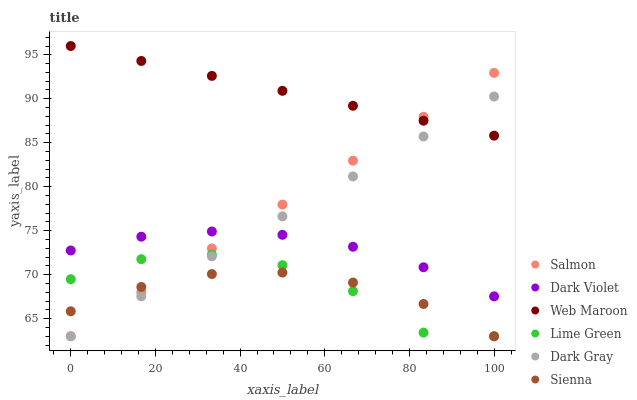Does Sienna have the minimum area under the curve?
Answer yes or no. Yes. Does Web Maroon have the maximum area under the curve?
Answer yes or no. Yes. Does Salmon have the minimum area under the curve?
Answer yes or no. No. Does Salmon have the maximum area under the curve?
Answer yes or no. No. Is Web Maroon the smoothest?
Answer yes or no. Yes. Is Lime Green the roughest?
Answer yes or no. Yes. Is Salmon the smoothest?
Answer yes or no. No. Is Salmon the roughest?
Answer yes or no. No. Does Sienna have the lowest value?
Answer yes or no. Yes. Does Web Maroon have the lowest value?
Answer yes or no. No. Does Web Maroon have the highest value?
Answer yes or no. Yes. Does Salmon have the highest value?
Answer yes or no. No. Is Lime Green less than Web Maroon?
Answer yes or no. Yes. Is Web Maroon greater than Dark Violet?
Answer yes or no. Yes. Does Dark Violet intersect Dark Gray?
Answer yes or no. Yes. Is Dark Violet less than Dark Gray?
Answer yes or no. No. Is Dark Violet greater than Dark Gray?
Answer yes or no. No. Does Lime Green intersect Web Maroon?
Answer yes or no. No. 